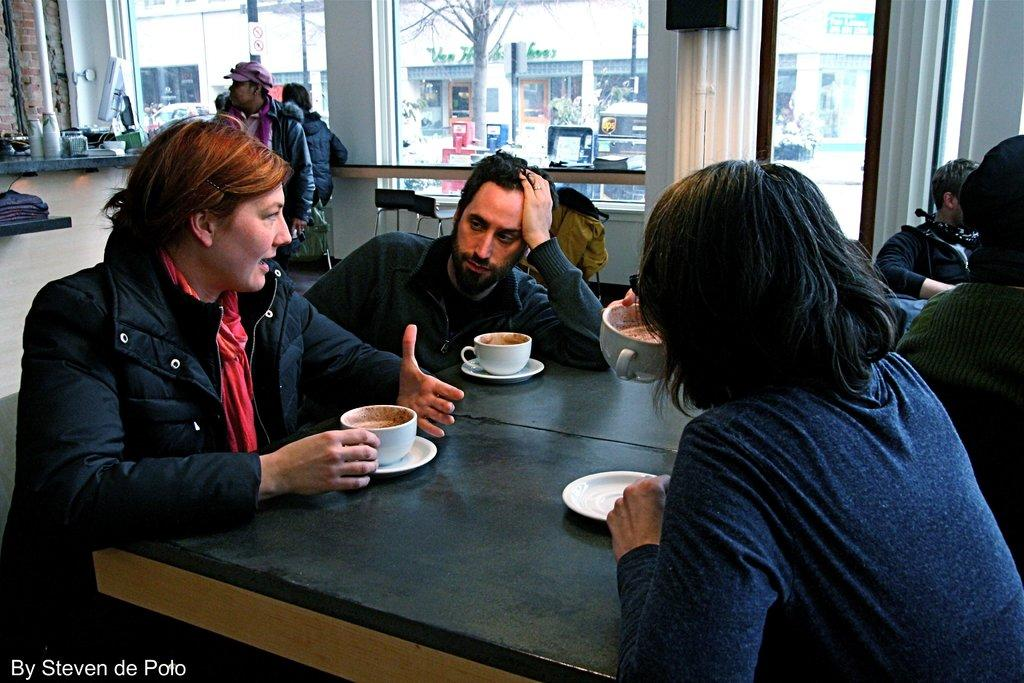What are the persons in the image doing? The persons in the image are sitting around a table. What are they consuming at the table? They are having coffee. What can be seen in the background of the image? There are shops and trees in the background of the image. Are there any other persons visible in the image? Yes, there is a group of persons in the background of the image. What type of expansion is visible on the table in the image? There is no visible expansion on the table in the image. Can you describe the throne that is present in the image? There is no throne present in the image. 